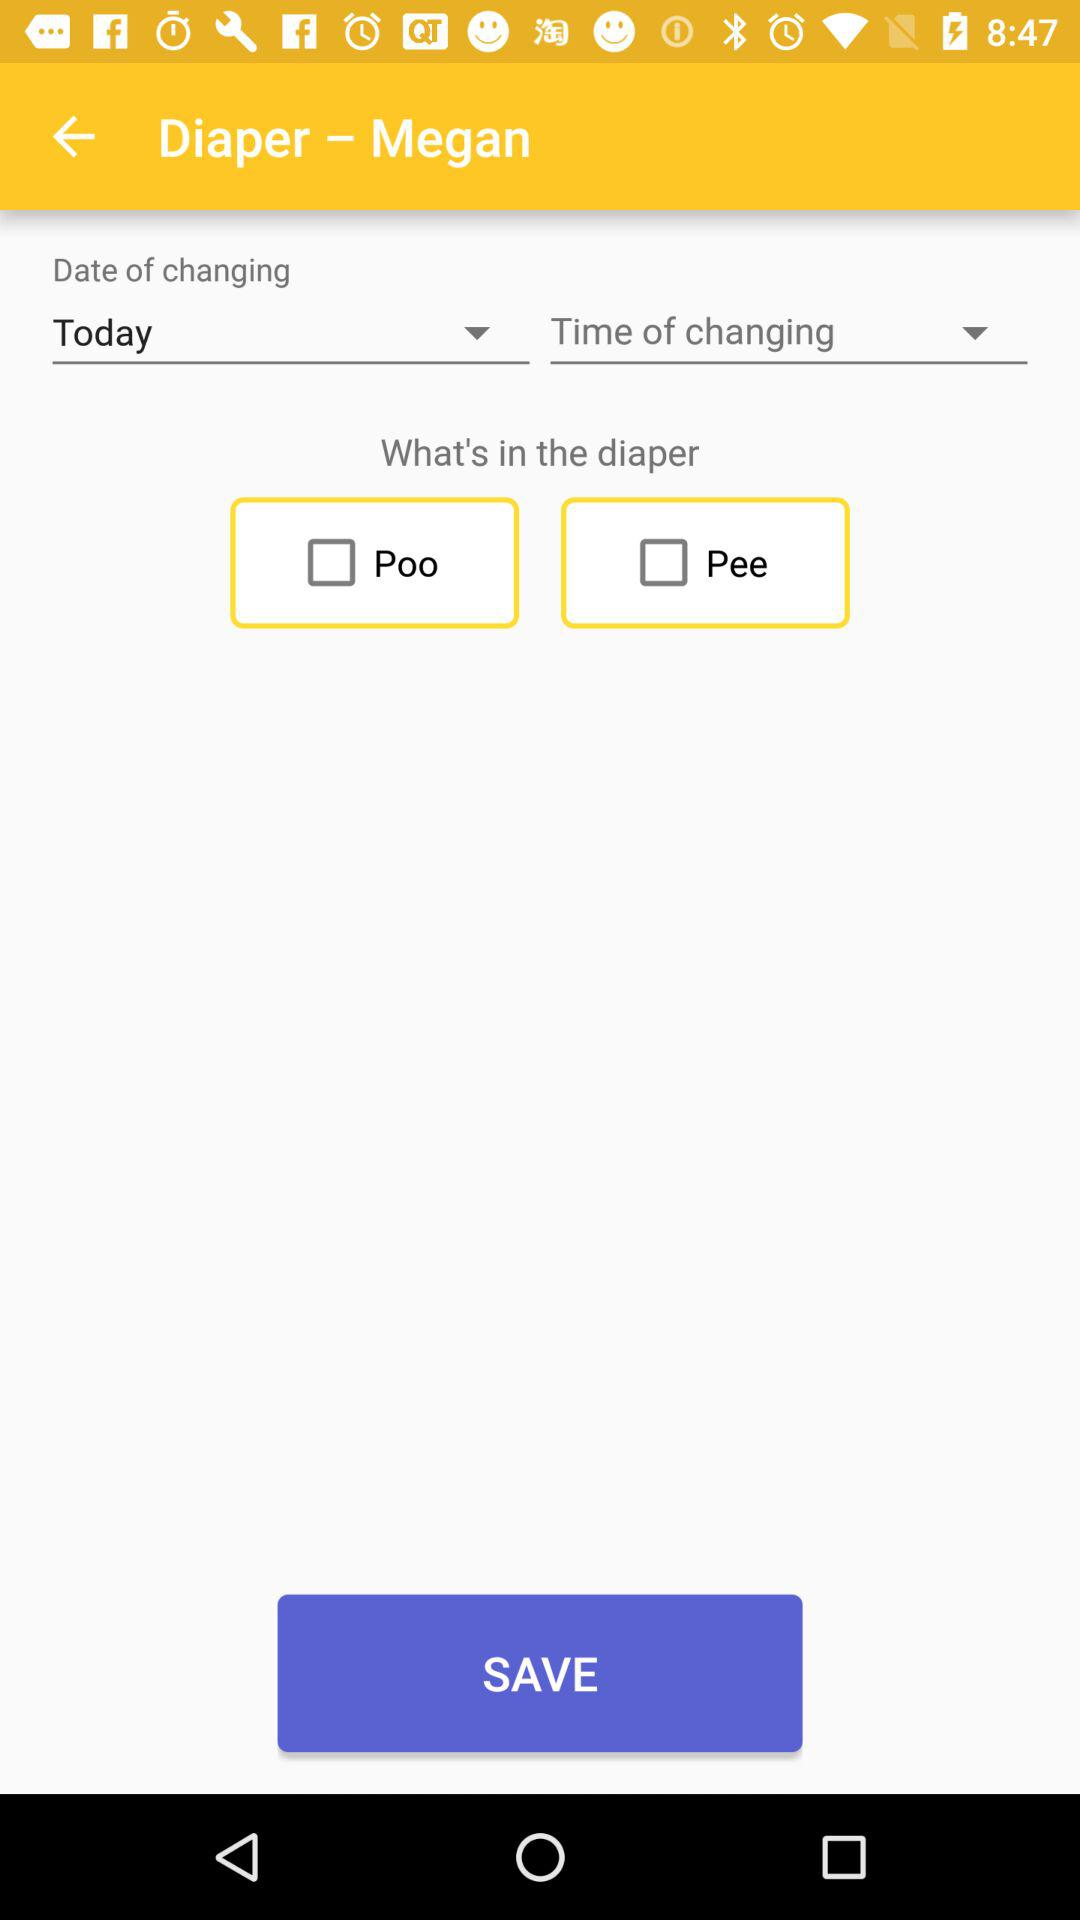What is the selected "Date of changing"? The selected "Date of changing" is "Today". 